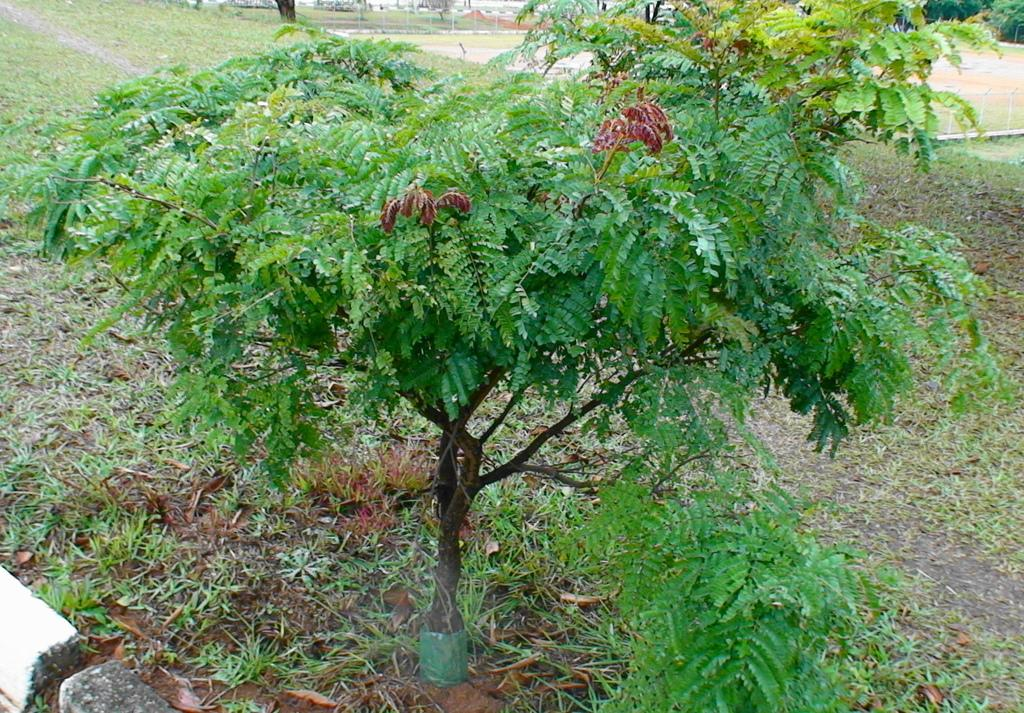What is the main feature of the landscape in the image? There is an open green grass ground in the image. Are there any other natural elements present in the image? Yes, there is a tree in the image. What type of shoe is the actor wearing in the image? There is no actor or shoe present in the image; it features an open green grass ground and a tree. 